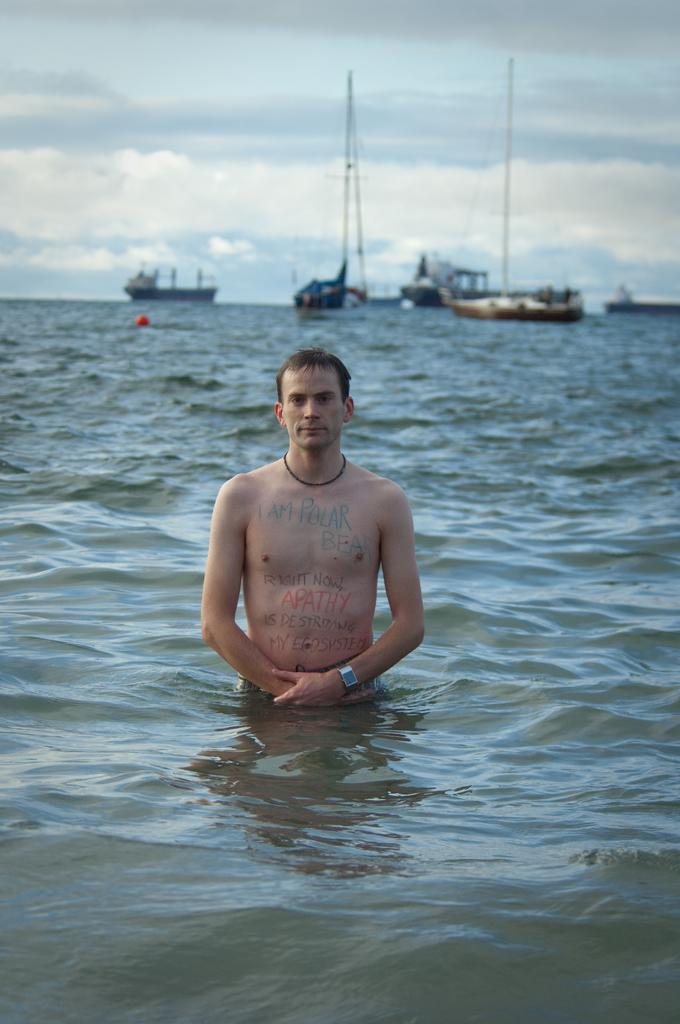What is the person in the image doing? The person is standing in a water body. What can be seen in the background of the image? There are ships in the background of the image. How would you describe the sky in the image? The sky is cloudy. Are there any markings or writings on the person's body? Yes, there are texts on the man's body. What type of cord is being used to control the sky in the image? There is no cord present in the image, and the sky is not being controlled. 